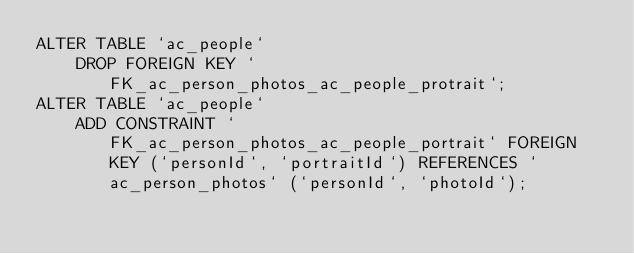Convert code to text. <code><loc_0><loc_0><loc_500><loc_500><_SQL_>ALTER TABLE `ac_people`
	DROP FOREIGN KEY `FK_ac_person_photos_ac_people_protrait`;
ALTER TABLE `ac_people`
	ADD CONSTRAINT `FK_ac_person_photos_ac_people_portrait` FOREIGN KEY (`personId`, `portraitId`) REFERENCES `ac_person_photos` (`personId`, `photoId`);
</code> 